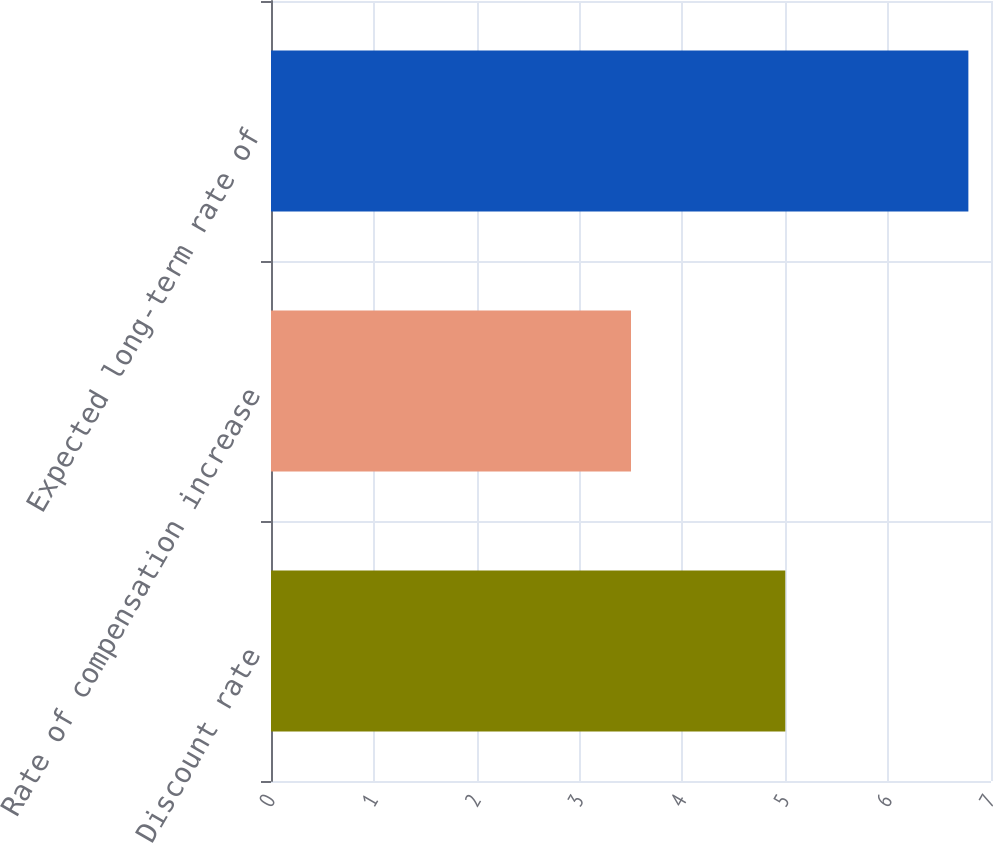<chart> <loc_0><loc_0><loc_500><loc_500><bar_chart><fcel>Discount rate<fcel>Rate of compensation increase<fcel>Expected long-term rate of<nl><fcel>5<fcel>3.5<fcel>6.78<nl></chart> 